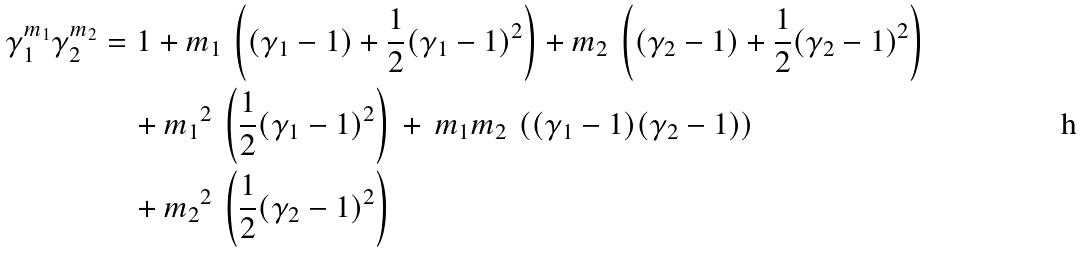<formula> <loc_0><loc_0><loc_500><loc_500>\gamma _ { 1 } ^ { m _ { 1 } } \gamma _ { 2 } ^ { m _ { 2 } } & = 1 + m _ { 1 } \, \left ( ( \gamma _ { 1 } - 1 ) + \frac { 1 } { 2 } ( \gamma _ { 1 } - 1 ) ^ { 2 } \right ) + m _ { 2 } \, \left ( ( \gamma _ { 2 } - 1 ) + \frac { 1 } { 2 } ( \gamma _ { 2 } - 1 ) ^ { 2 } \right ) \\ & \quad + { m _ { 1 } } ^ { 2 } \, \left ( \frac { 1 } { 2 } ( \gamma _ { 1 } - 1 ) ^ { 2 } \right ) \, + \, m _ { 1 } m _ { 2 } \, \left ( ( \gamma _ { 1 } - 1 ) ( \gamma _ { 2 } - 1 ) \right ) \\ & \quad + { m _ { 2 } } ^ { 2 } \, \left ( \frac { 1 } { 2 } ( \gamma _ { 2 } - 1 ) ^ { 2 } \right )</formula> 